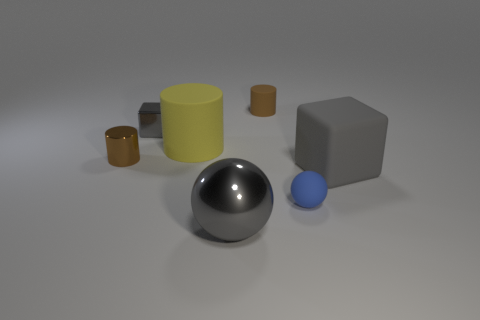What material is the other block that is the same color as the big cube?
Ensure brevity in your answer.  Metal. What number of things are either cubes that are in front of the metallic block or objects that are right of the metallic block?
Ensure brevity in your answer.  5. Does the brown thing that is to the left of the tiny rubber cylinder have the same size as the gray metallic object that is in front of the large yellow cylinder?
Keep it short and to the point. No. What is the color of the other rubber thing that is the same shape as the tiny gray object?
Your answer should be very brief. Gray. Is there anything else that has the same shape as the small brown matte thing?
Make the answer very short. Yes. Are there more brown rubber objects that are on the left side of the gray metallic cube than small gray cubes that are in front of the yellow rubber thing?
Your answer should be very brief. No. What size is the brown object to the right of the rubber thing that is to the left of the small brown cylinder right of the large gray ball?
Your answer should be compact. Small. Are the tiny sphere and the tiny brown object that is on the left side of the gray shiny cube made of the same material?
Ensure brevity in your answer.  No. Does the yellow thing have the same shape as the gray rubber thing?
Give a very brief answer. No. What number of other objects are there of the same material as the large gray cube?
Make the answer very short. 3. 